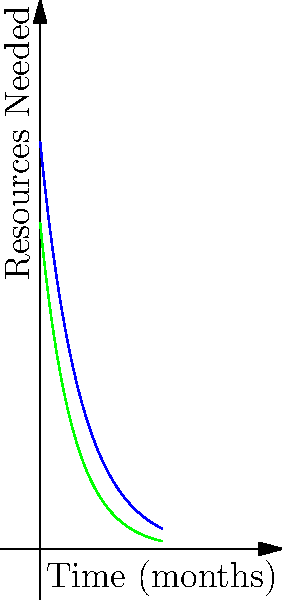Given the resource allocation curves for Jewish and Muslim communities in a healthcare optimization problem, at what point in time (in months) will both communities require the same amount of resources? To solve this problem, we need to follow these steps:

1) The resource needs for the Jewish community are represented by the function:
   $$f(x) = 100e^{-x/10}$$

2) The resource needs for the Muslim community are represented by the function:
   $$g(x) = 80e^{-x/8}$$

3) To find when both communities require the same resources, we set the equations equal:
   $$100e^{-x/10} = 80e^{-x/8}$$

4) Simplify by dividing both sides by 20:
   $$5e^{-x/10} = 4e^{-x/8}$$

5) Take the natural log of both sides:
   $$\ln(5) - \frac{x}{10} = \ln(4) - \frac{x}{8}$$

6) Multiply both sides by 40 to eliminate fractions:
   $$40\ln(5) - 4x = 40\ln(4) - 5x$$

7) Subtract 40ln(4) from both sides:
   $$40\ln(5) - 40\ln(4) = x$$

8) Simplify:
   $$40(\ln(5) - \ln(4)) = x$$

9) Calculate the value (you can use a calculator for this):
   $$x \approx 9.2$$

Therefore, both communities will require the same amount of resources after approximately 9.2 months.
Answer: 9.2 months 